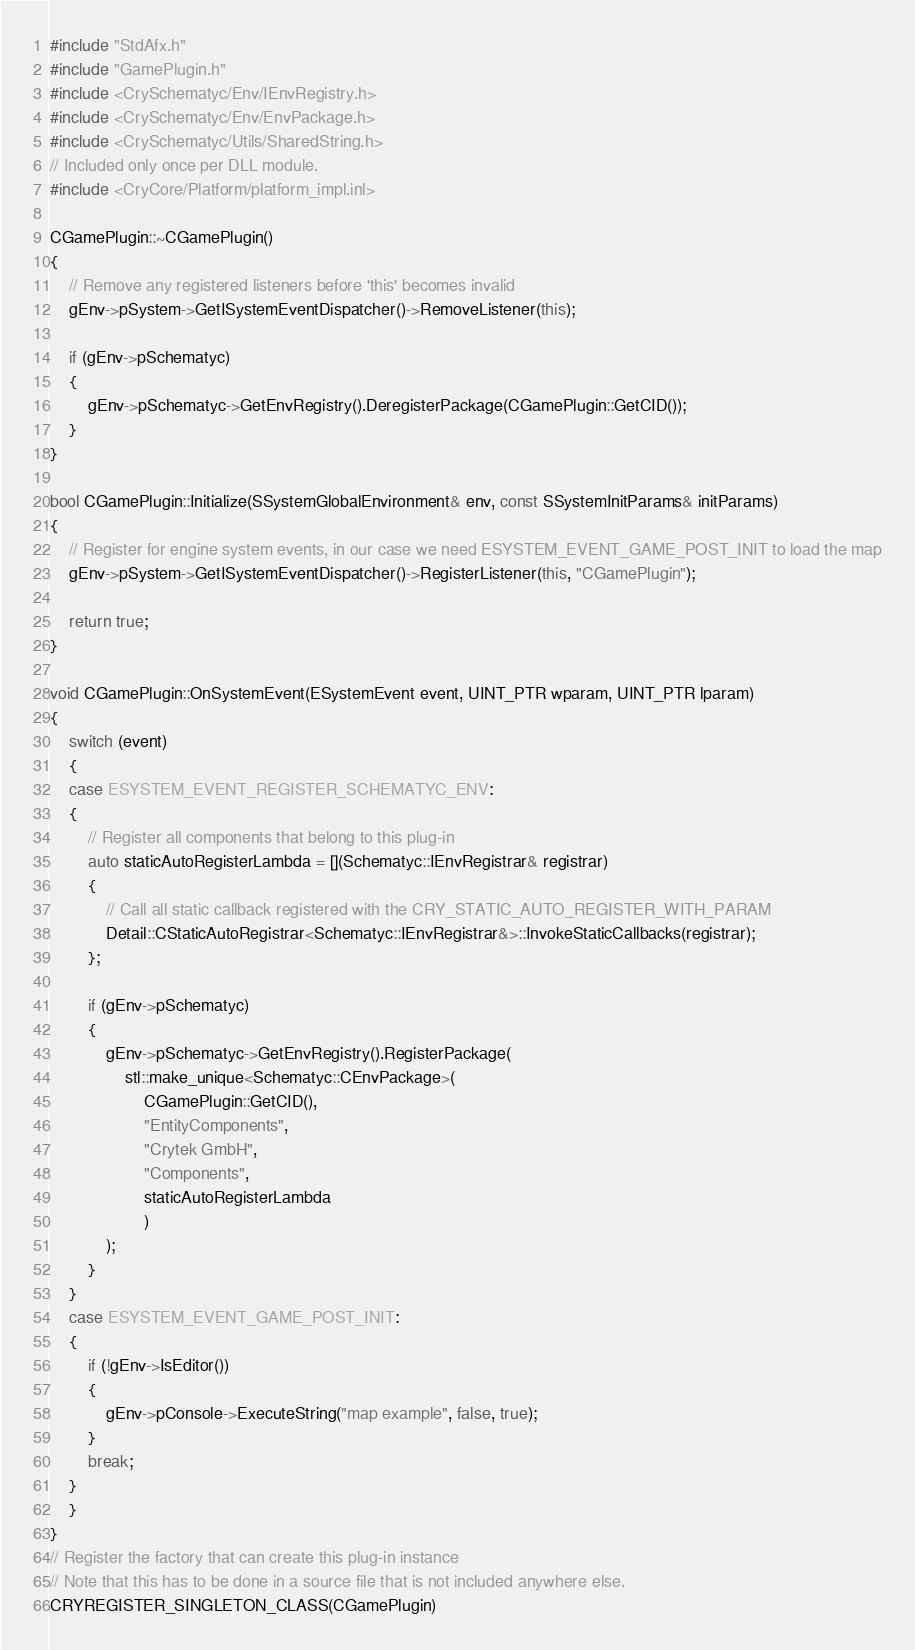Convert code to text. <code><loc_0><loc_0><loc_500><loc_500><_C++_>#include "StdAfx.h"
#include "GamePlugin.h"
#include <CrySchematyc/Env/IEnvRegistry.h>
#include <CrySchematyc/Env/EnvPackage.h>
#include <CrySchematyc/Utils/SharedString.h>
// Included only once per DLL module.
#include <CryCore/Platform/platform_impl.inl>

CGamePlugin::~CGamePlugin()
{
	// Remove any registered listeners before 'this' becomes invalid
	gEnv->pSystem->GetISystemEventDispatcher()->RemoveListener(this);

	if (gEnv->pSchematyc)
	{
		gEnv->pSchematyc->GetEnvRegistry().DeregisterPackage(CGamePlugin::GetCID());
	}
}

bool CGamePlugin::Initialize(SSystemGlobalEnvironment& env, const SSystemInitParams& initParams)
{
	// Register for engine system events, in our case we need ESYSTEM_EVENT_GAME_POST_INIT to load the map
	gEnv->pSystem->GetISystemEventDispatcher()->RegisterListener(this, "CGamePlugin");

	return true;
}

void CGamePlugin::OnSystemEvent(ESystemEvent event, UINT_PTR wparam, UINT_PTR lparam)
{
	switch (event)
	{
	case ESYSTEM_EVENT_REGISTER_SCHEMATYC_ENV:
	{
		// Register all components that belong to this plug-in
		auto staticAutoRegisterLambda = [](Schematyc::IEnvRegistrar& registrar)
		{
			// Call all static callback registered with the CRY_STATIC_AUTO_REGISTER_WITH_PARAM
			Detail::CStaticAutoRegistrar<Schematyc::IEnvRegistrar&>::InvokeStaticCallbacks(registrar);
		};

		if (gEnv->pSchematyc)
		{
			gEnv->pSchematyc->GetEnvRegistry().RegisterPackage(
				stl::make_unique<Schematyc::CEnvPackage>(
					CGamePlugin::GetCID(),
					"EntityComponents",
					"Crytek GmbH",
					"Components",
					staticAutoRegisterLambda
					)
			);
		}
	}
	case ESYSTEM_EVENT_GAME_POST_INIT:
	{
		if (!gEnv->IsEditor())
		{
			gEnv->pConsole->ExecuteString("map example", false, true);
		}
		break;
	}
	}
}
// Register the factory that can create this plug-in instance
// Note that this has to be done in a source file that is not included anywhere else.
CRYREGISTER_SINGLETON_CLASS(CGamePlugin)
</code> 